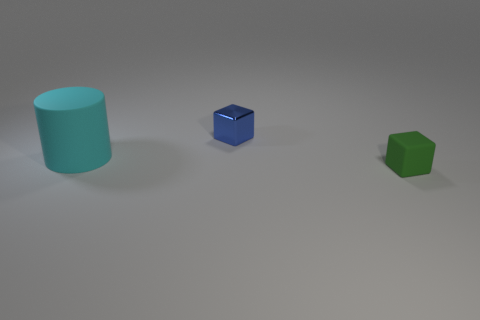Does the object behind the big cyan matte object have the same shape as the large rubber thing?
Offer a very short reply. No. How many green things are small blocks or big matte balls?
Your answer should be compact. 1. There is a small green thing that is the same shape as the tiny blue thing; what material is it?
Make the answer very short. Rubber. What is the shape of the matte object behind the small green rubber object?
Ensure brevity in your answer.  Cylinder. Are there any big yellow cubes that have the same material as the big cyan object?
Keep it short and to the point. No. Do the rubber block and the blue block have the same size?
Keep it short and to the point. Yes. How many spheres are either small matte things or blue things?
Your answer should be compact. 0. What number of tiny purple objects have the same shape as the blue metal thing?
Your answer should be very brief. 0. Is the number of objects that are behind the tiny green object greater than the number of blocks on the left side of the tiny blue block?
Ensure brevity in your answer.  Yes. Does the matte object to the left of the blue metallic object have the same color as the tiny matte cube?
Your response must be concise. No. 